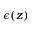<formula> <loc_0><loc_0><loc_500><loc_500>\epsilon ( z )</formula> 